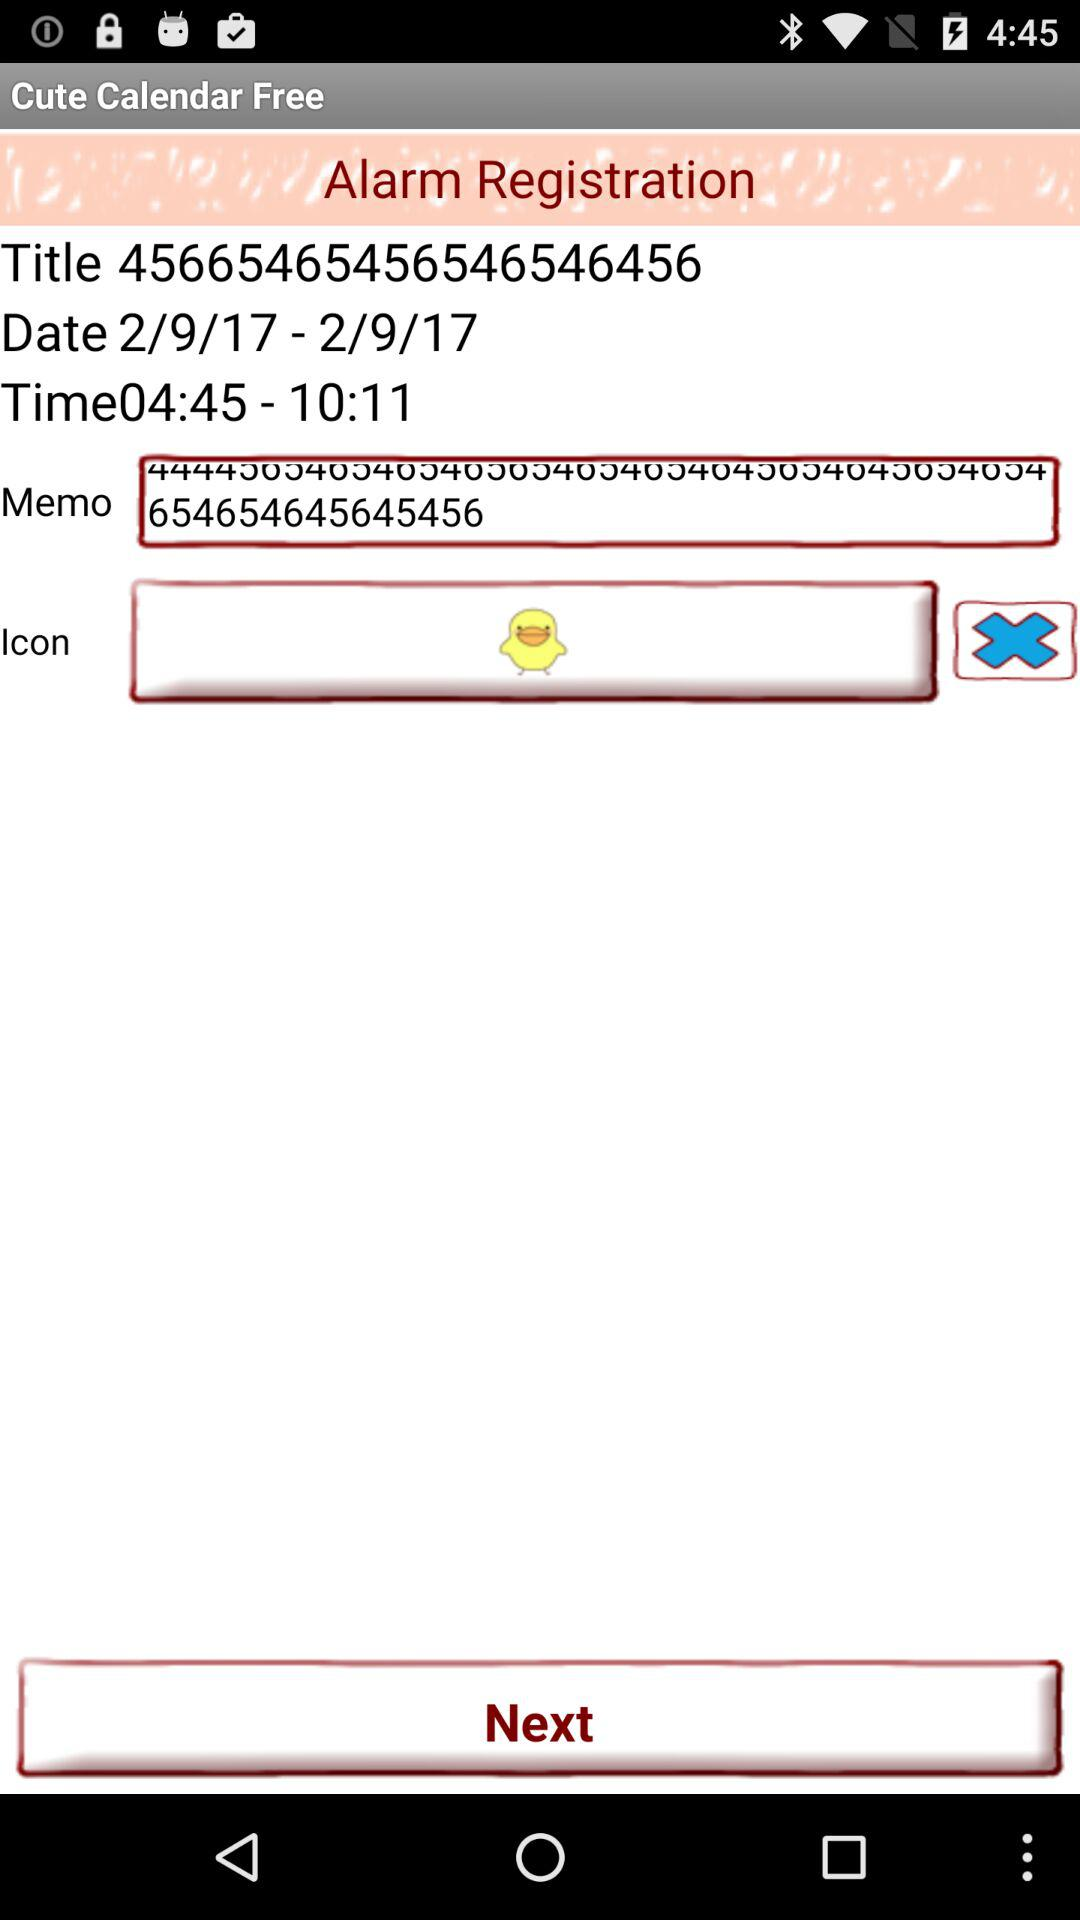Is the app free or paid? The app is free. 